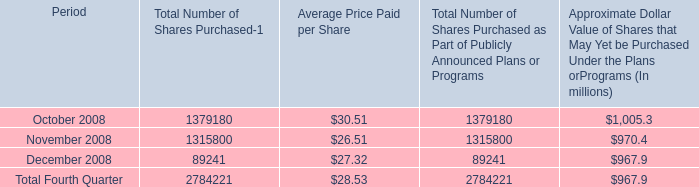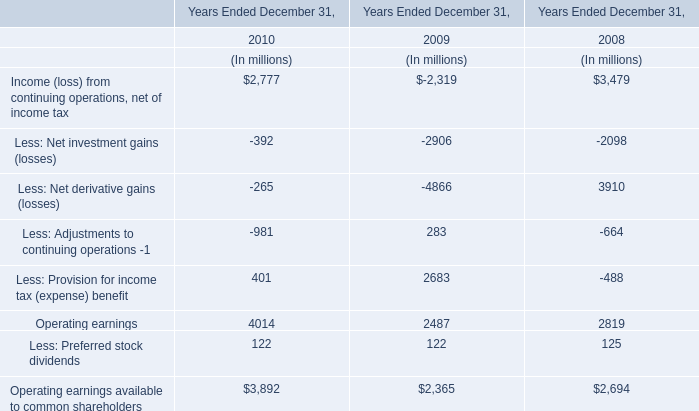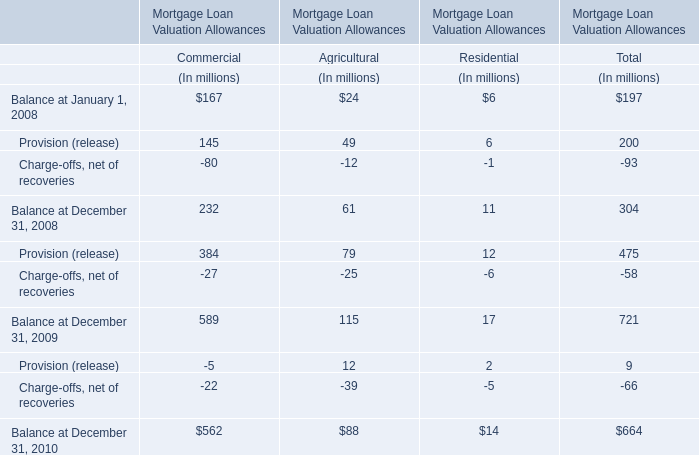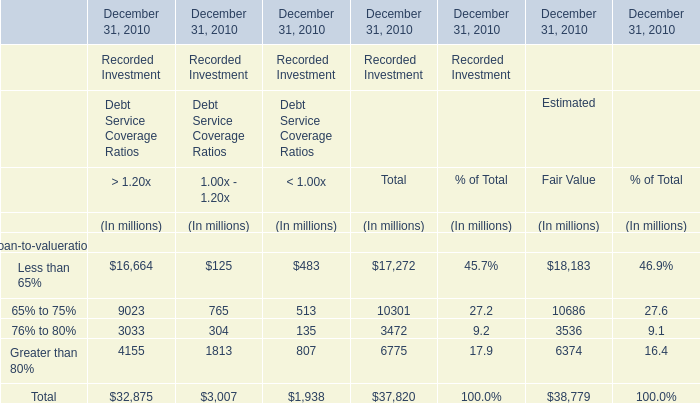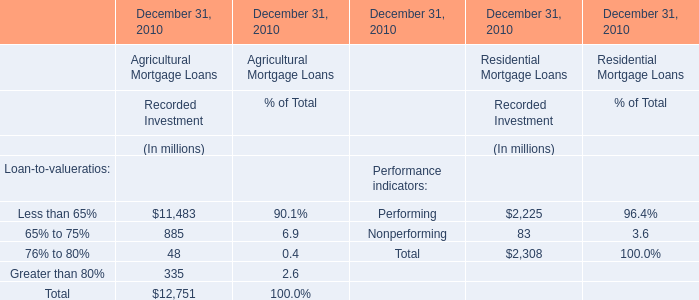What do all Recorded Investment for Agricultural Mortgage Loans at December 31, 2010 in As the chart 4 sum up , excluding those lower than 10000 million? (in million) 
Answer: 11483. 